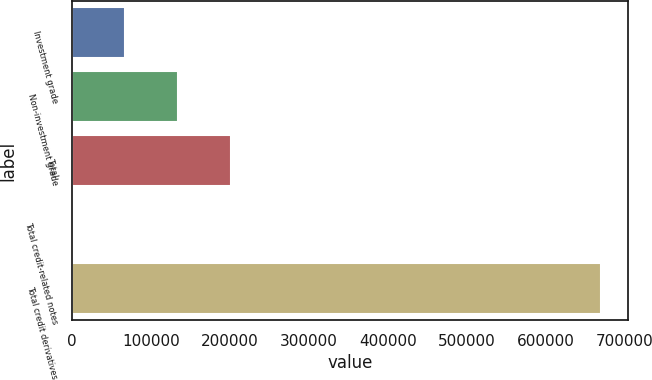Convert chart. <chart><loc_0><loc_0><loc_500><loc_500><bar_chart><fcel>Investment grade<fcel>Non-investment grade<fcel>Total<fcel>Total credit-related notes<fcel>Total credit derivatives<nl><fcel>67252.5<fcel>134331<fcel>201410<fcel>174<fcel>670959<nl></chart> 